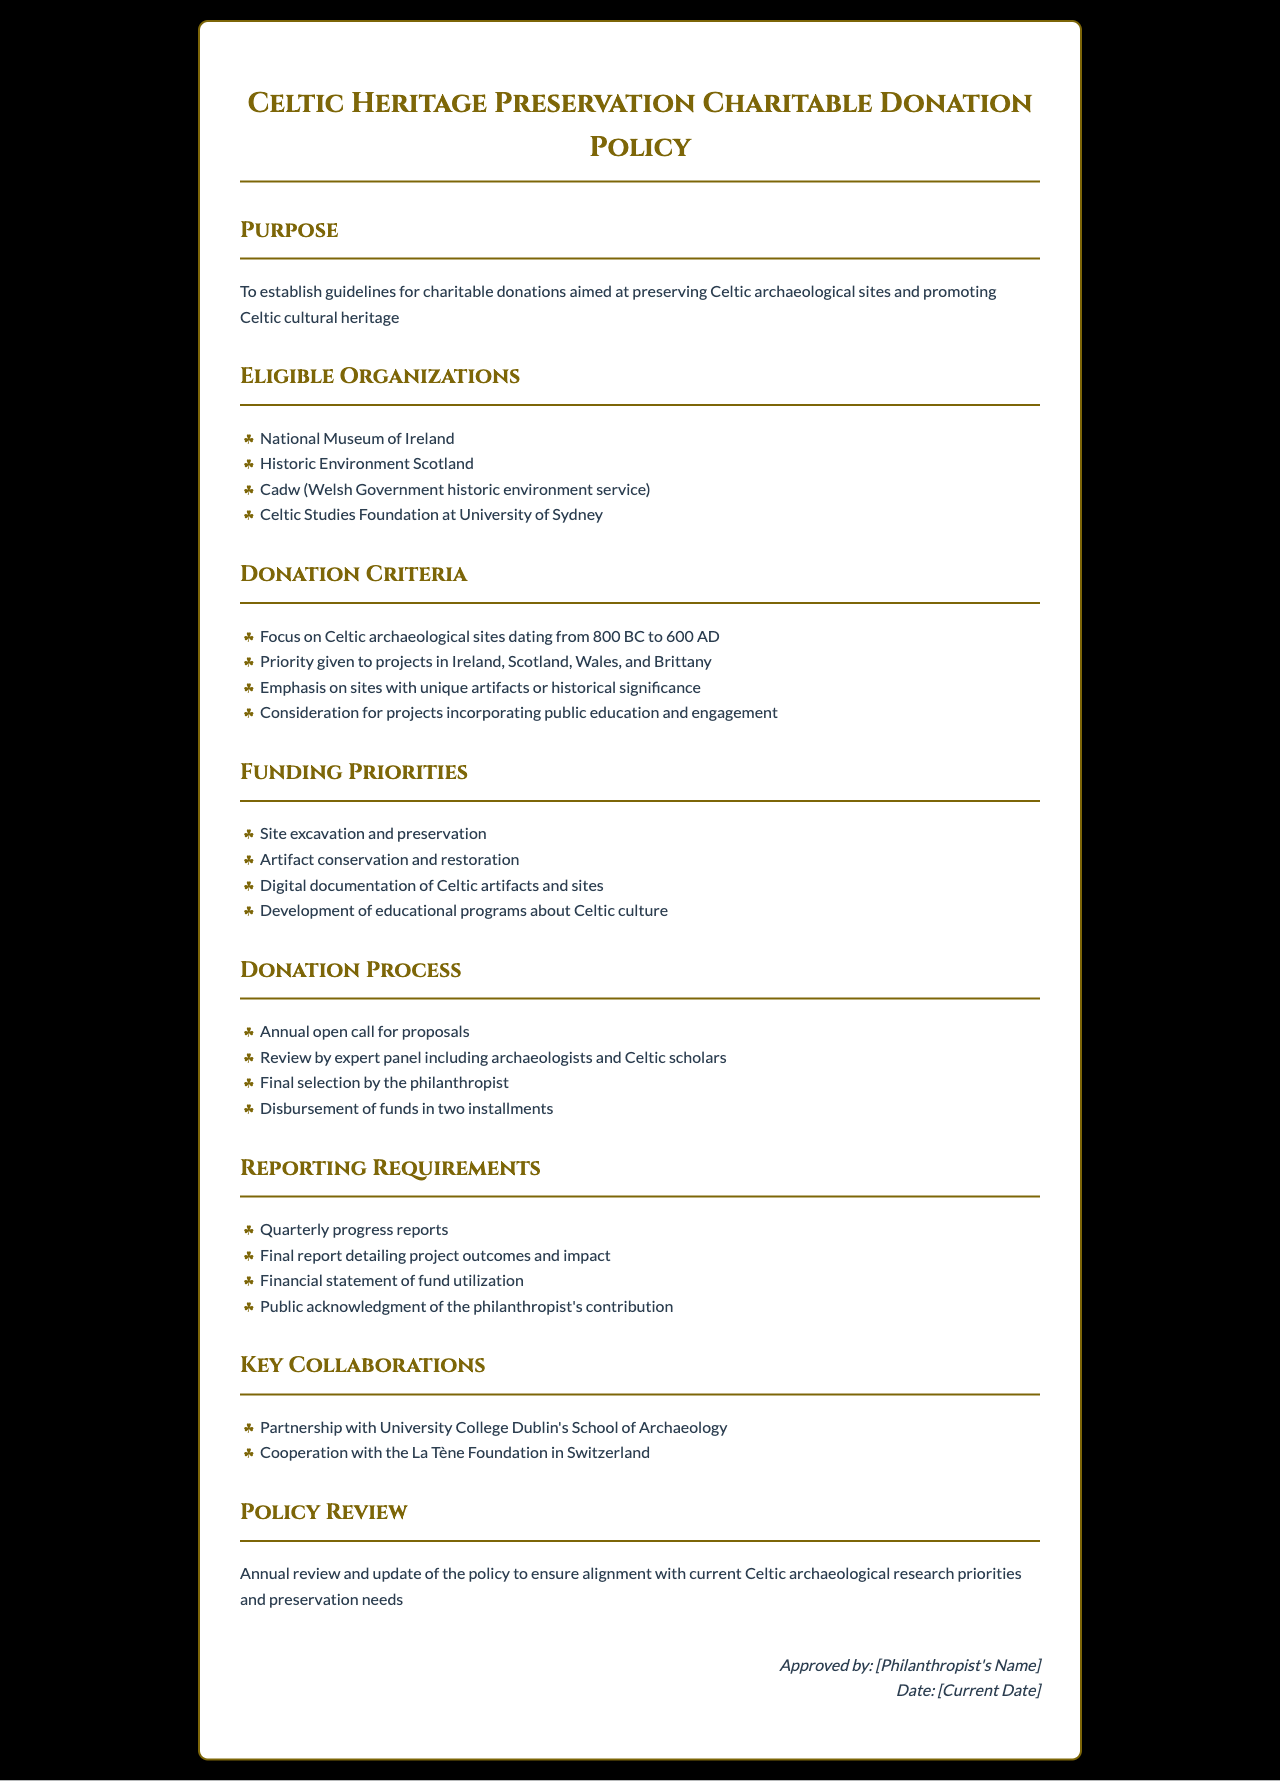What is the purpose of the policy? The purpose is to establish guidelines for charitable donations aimed at preserving Celtic archaeological sites and promoting Celtic cultural heritage.
Answer: To establish guidelines for charitable donations aimed at preserving Celtic archaeological sites and promoting Celtic cultural heritage Which organizations are eligible for donations? The document lists four eligible organizations involved in Celtic heritage preservation.
Answer: National Museum of Ireland, Historic Environment Scotland, Cadw, Celtic Studies Foundation at University of Sydney What is the donation focus timeframe? The document specifies a date range for focusing on Celtic archaeological sites for donations.
Answer: 800 BC to 600 AD What is a priority for funding projects? The document mentions priorities for funding projects related to Celtic heritage.
Answer: Site excavation and preservation What type of reports are required from funded projects? The document describes reporting requirements for projects that receive funding.
Answer: Quarterly progress reports What is the frequency of the policy review? The document states how often the policy will be reviewed to ensure it remains relevant.
Answer: Annual Who finalizes the selection of the proposals? The document indicates who is responsible for the final selection of project proposals.
Answer: The philanthropist What partnership is mentioned in the key collaborations? The document details a specific partnership relevant to Celtic archaeological research.
Answer: University College Dublin's School of Archaeology 